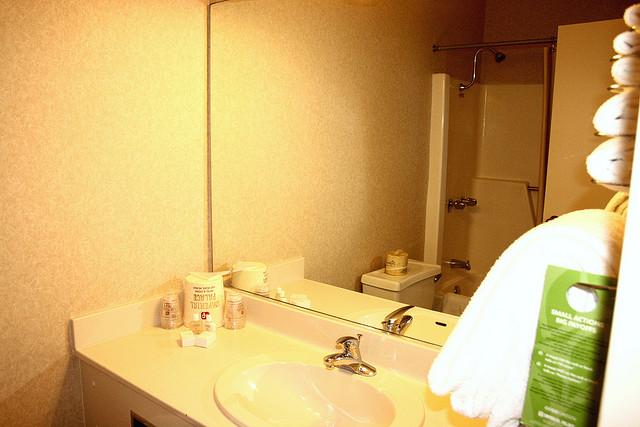Is this a kitchen?
Short answer required. No. What color is the sink?
Write a very short answer. White. Is this in someone's home?
Short answer required. No. 